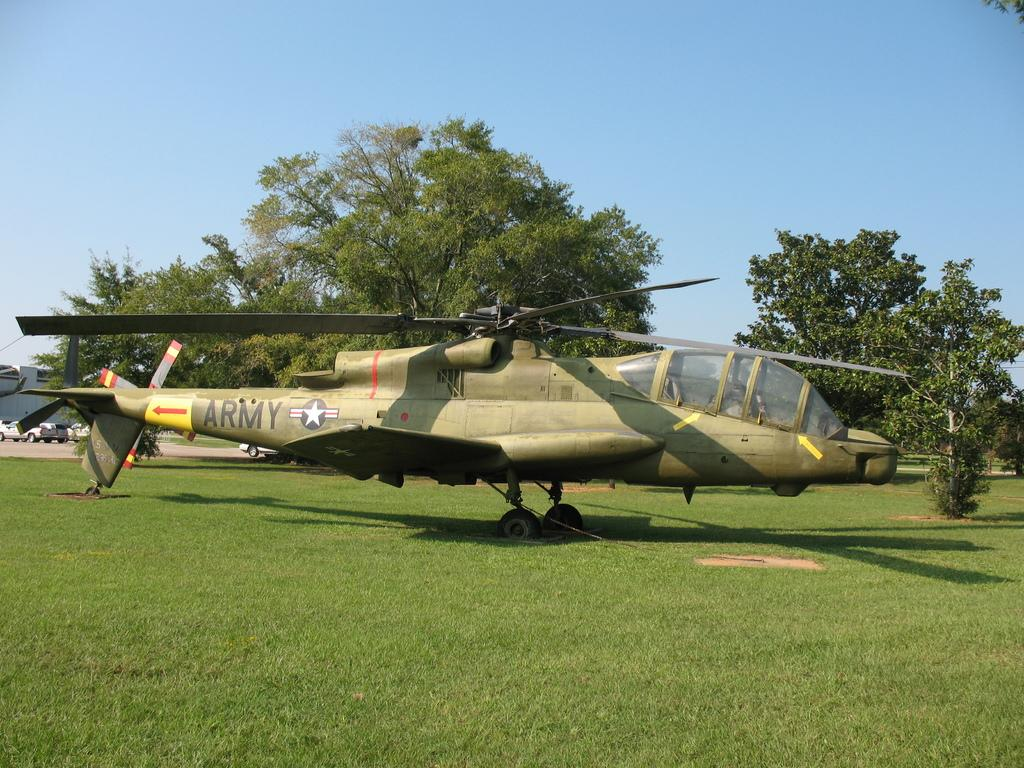<image>
Offer a succinct explanation of the picture presented. A helicopter with the word ARMY written across its tail. 